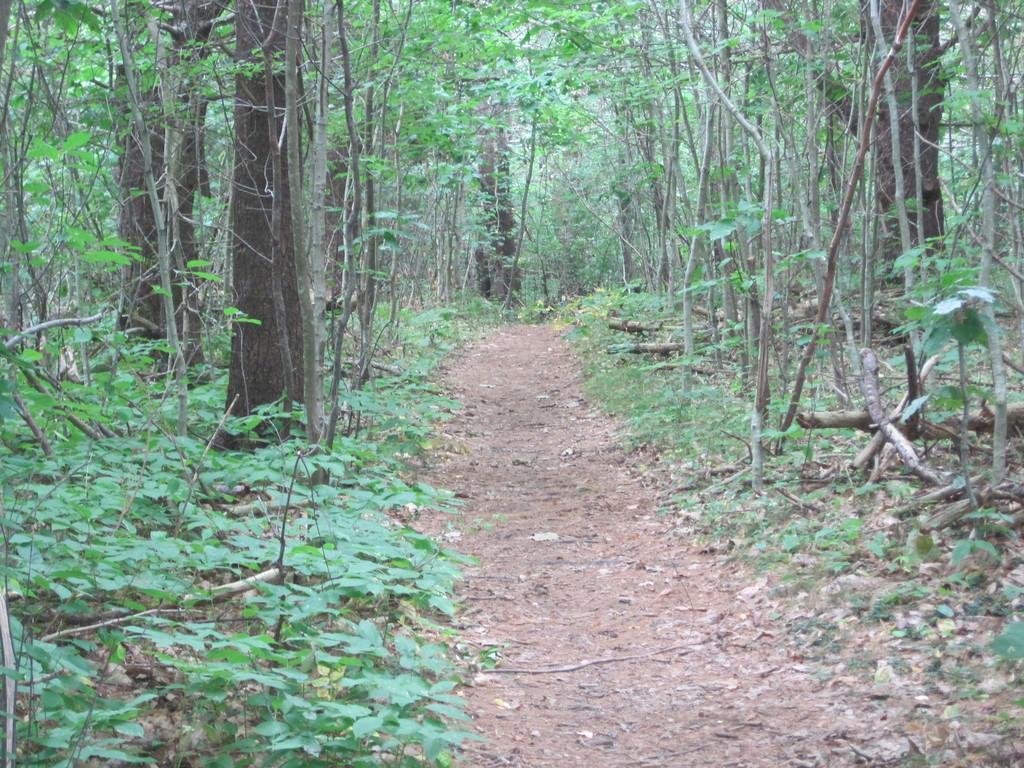How would you summarize this image in a sentence or two? In this image, we can see a path in between trees and plants. 